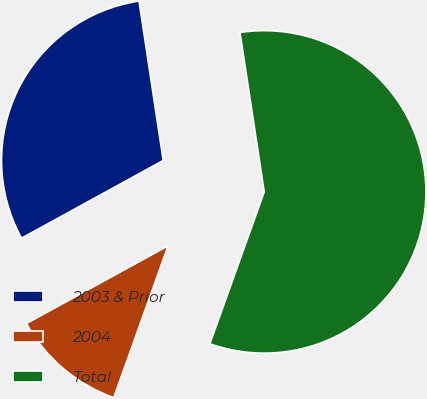Convert chart to OTSL. <chart><loc_0><loc_0><loc_500><loc_500><pie_chart><fcel>2003 & Prior<fcel>2004<fcel>Total<nl><fcel>30.61%<fcel>11.54%<fcel>57.85%<nl></chart> 